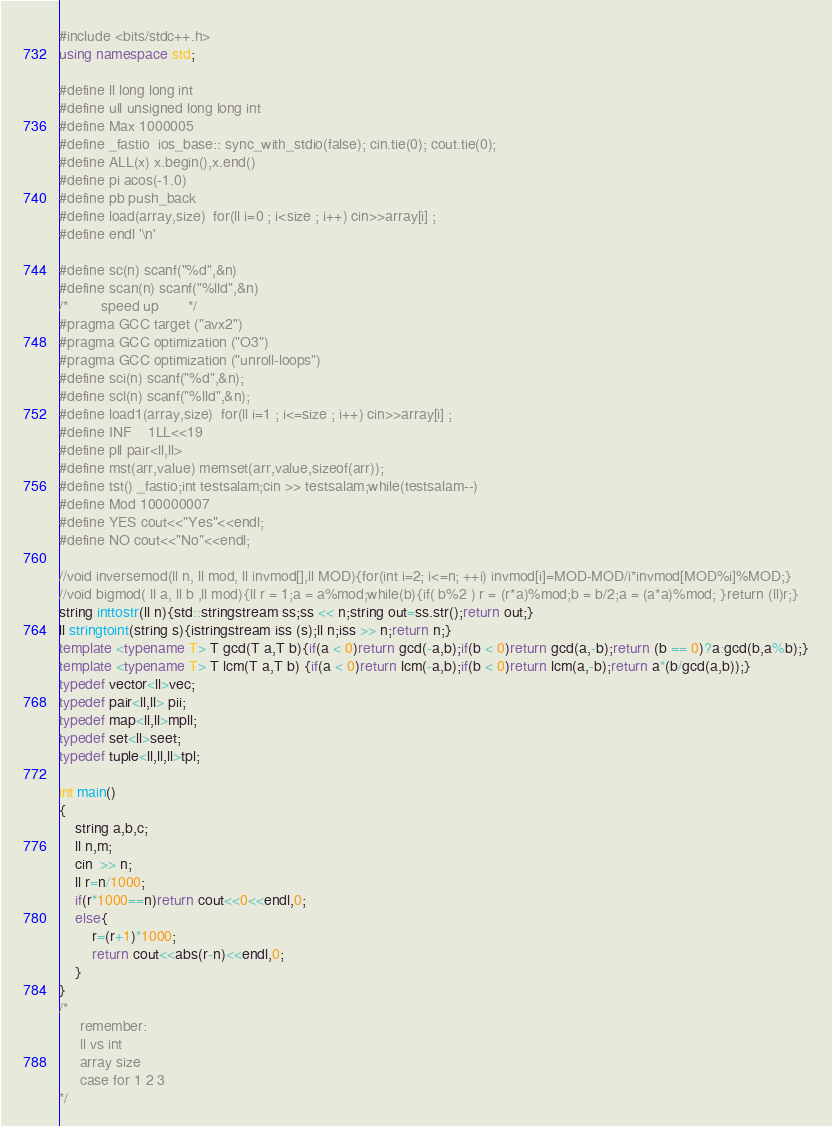<code> <loc_0><loc_0><loc_500><loc_500><_C++_>


#include <bits/stdc++.h>
using namespace std;

#define ll long long int
#define ull unsigned long long int
#define Max 1000005
#define _fastio  ios_base:: sync_with_stdio(false); cin.tie(0); cout.tie(0);
#define ALL(x) x.begin(),x.end()
#define pi acos(-1.0)
#define pb push_back
#define load(array,size)  for(ll i=0 ; i<size ; i++) cin>>array[i] ;
#define endl '\n'

#define sc(n) scanf("%d",&n)
#define scan(n) scanf("%lld",&n)
/*        speed up       */
#pragma GCC target ("avx2")
#pragma GCC optimization ("O3")
#pragma GCC optimization ("unroll-loops")
#define sci(n) scanf("%d",&n);
#define scl(n) scanf("%lld",&n);
#define load1(array,size)  for(ll i=1 ; i<=size ; i++) cin>>array[i] ;
#define INF    1LL<<19
#define pll pair<ll,ll>
#define mst(arr,value) memset(arr,value,sizeof(arr));
#define tst() _fastio;int testsalam;cin >> testsalam;while(testsalam--)
#define Mod 100000007
#define YES cout<<"Yes"<<endl;
#define NO cout<<"No"<<endl;

//void inversemod(ll n, ll mod, ll invmod[],ll MOD){for(int i=2; i<=n; ++i) invmod[i]=MOD-MOD/i*invmod[MOD%i]%MOD;}
//void bigmod( ll a, ll b ,ll mod){ll r = 1;a = a%mod;while(b){if( b%2 ) r = (r*a)%mod;b = b/2;a = (a*a)%mod; }return (ll)r;}
string inttostr(ll n){std::stringstream ss;ss << n;string out=ss.str();return out;}
ll stringtoint(string s){istringstream iss (s);ll n;iss >> n;return n;}
template <typename T> T gcd(T a,T b){if(a < 0)return gcd(-a,b);if(b < 0)return gcd(a,-b);return (b == 0)?a:gcd(b,a%b);}
template <typename T> T lcm(T a,T b) {if(a < 0)return lcm(-a,b);if(b < 0)return lcm(a,-b);return a*(b/gcd(a,b));}
typedef vector<ll>vec;
typedef pair<ll,ll> pii;
typedef map<ll,ll>mpll;
typedef set<ll>seet;
typedef tuple<ll,ll,ll>tpl;

int main()
{
    string a,b,c;
    ll n,m;
    cin  >> n;
    ll r=n/1000;
    if(r*1000==n)return cout<<0<<endl,0;
    else{
    	r=(r+1)*1000;
    	return cout<<abs(r-n)<<endl,0;
    }
}
/*
     remember:
     ll vs int
     array size
     case for 1 2 3 
*/

</code> 